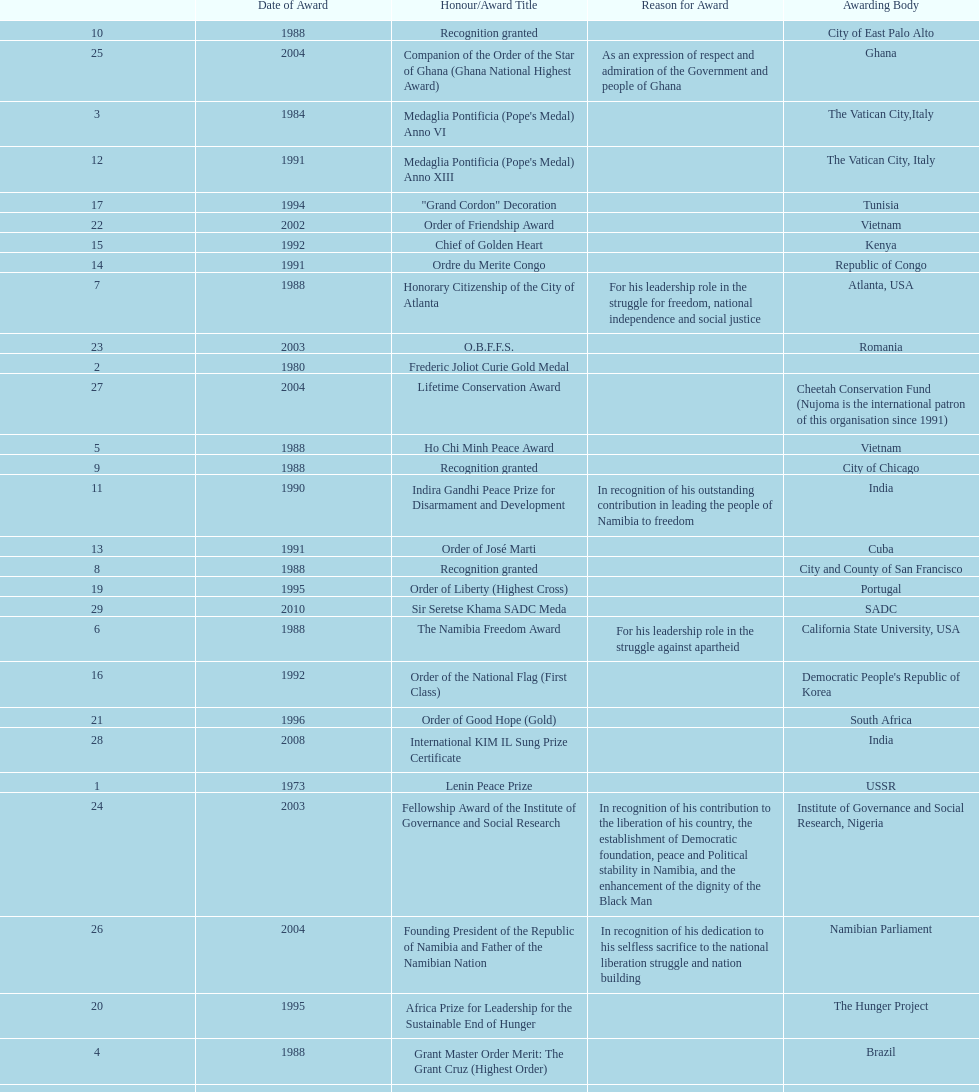Which year was the most honors/award titles given? 1988. 